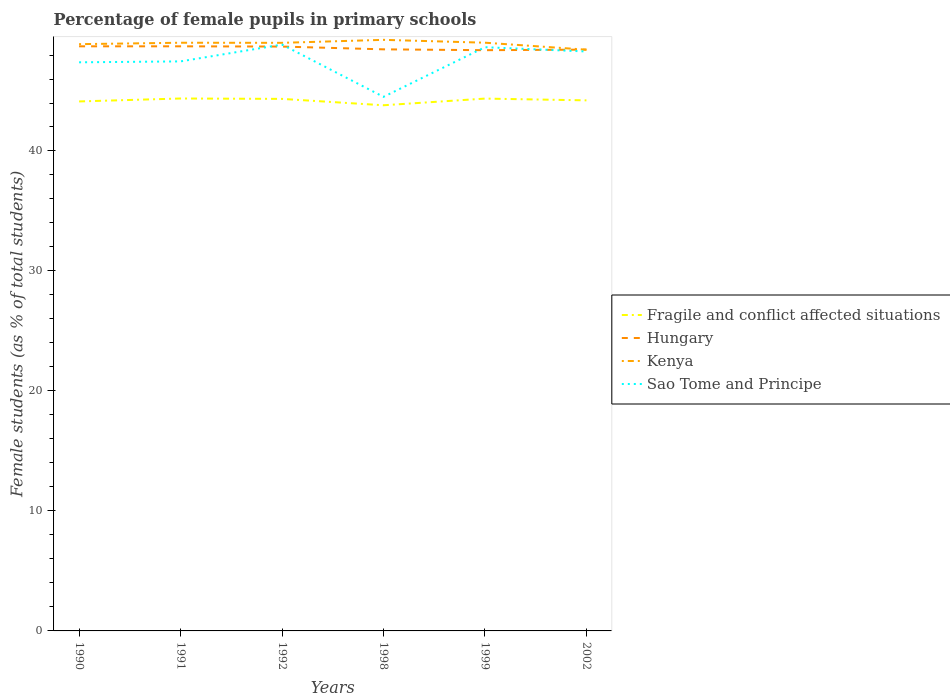Does the line corresponding to Kenya intersect with the line corresponding to Fragile and conflict affected situations?
Your response must be concise. No. Is the number of lines equal to the number of legend labels?
Your answer should be very brief. Yes. Across all years, what is the maximum percentage of female pupils in primary schools in Kenya?
Keep it short and to the point. 48.44. In which year was the percentage of female pupils in primary schools in Sao Tome and Principe maximum?
Provide a succinct answer. 1998. What is the total percentage of female pupils in primary schools in Hungary in the graph?
Your answer should be compact. 0.25. What is the difference between the highest and the second highest percentage of female pupils in primary schools in Fragile and conflict affected situations?
Ensure brevity in your answer.  0.56. Is the percentage of female pupils in primary schools in Hungary strictly greater than the percentage of female pupils in primary schools in Kenya over the years?
Offer a terse response. No. How many lines are there?
Offer a very short reply. 4. How many years are there in the graph?
Your answer should be compact. 6. What is the difference between two consecutive major ticks on the Y-axis?
Your response must be concise. 10. Does the graph contain any zero values?
Ensure brevity in your answer.  No. How many legend labels are there?
Your answer should be very brief. 4. How are the legend labels stacked?
Offer a very short reply. Vertical. What is the title of the graph?
Ensure brevity in your answer.  Percentage of female pupils in primary schools. Does "Kiribati" appear as one of the legend labels in the graph?
Make the answer very short. No. What is the label or title of the Y-axis?
Keep it short and to the point. Female students (as % of total students). What is the Female students (as % of total students) in Fragile and conflict affected situations in 1990?
Make the answer very short. 44.13. What is the Female students (as % of total students) of Hungary in 1990?
Offer a terse response. 48.72. What is the Female students (as % of total students) in Kenya in 1990?
Make the answer very short. 48.9. What is the Female students (as % of total students) in Sao Tome and Principe in 1990?
Your answer should be compact. 47.39. What is the Female students (as % of total students) in Fragile and conflict affected situations in 1991?
Your answer should be compact. 44.38. What is the Female students (as % of total students) of Hungary in 1991?
Keep it short and to the point. 48.72. What is the Female students (as % of total students) in Kenya in 1991?
Your answer should be very brief. 49.02. What is the Female students (as % of total students) in Sao Tome and Principe in 1991?
Offer a very short reply. 47.47. What is the Female students (as % of total students) of Fragile and conflict affected situations in 1992?
Your answer should be compact. 44.34. What is the Female students (as % of total students) of Hungary in 1992?
Offer a terse response. 48.7. What is the Female students (as % of total students) in Kenya in 1992?
Provide a short and direct response. 49.02. What is the Female students (as % of total students) of Sao Tome and Principe in 1992?
Your answer should be very brief. 48.87. What is the Female students (as % of total students) of Fragile and conflict affected situations in 1998?
Offer a very short reply. 43.81. What is the Female students (as % of total students) of Hungary in 1998?
Ensure brevity in your answer.  48.47. What is the Female students (as % of total students) in Kenya in 1998?
Offer a terse response. 49.26. What is the Female students (as % of total students) of Sao Tome and Principe in 1998?
Give a very brief answer. 44.51. What is the Female students (as % of total students) of Fragile and conflict affected situations in 1999?
Ensure brevity in your answer.  44.37. What is the Female students (as % of total students) of Hungary in 1999?
Make the answer very short. 48.4. What is the Female students (as % of total students) of Kenya in 1999?
Make the answer very short. 49.03. What is the Female students (as % of total students) in Sao Tome and Principe in 1999?
Offer a very short reply. 48.65. What is the Female students (as % of total students) of Fragile and conflict affected situations in 2002?
Make the answer very short. 44.22. What is the Female students (as % of total students) in Hungary in 2002?
Keep it short and to the point. 48.45. What is the Female students (as % of total students) of Kenya in 2002?
Offer a terse response. 48.44. What is the Female students (as % of total students) in Sao Tome and Principe in 2002?
Provide a succinct answer. 48.29. Across all years, what is the maximum Female students (as % of total students) in Fragile and conflict affected situations?
Your answer should be compact. 44.38. Across all years, what is the maximum Female students (as % of total students) of Hungary?
Keep it short and to the point. 48.72. Across all years, what is the maximum Female students (as % of total students) in Kenya?
Offer a terse response. 49.26. Across all years, what is the maximum Female students (as % of total students) of Sao Tome and Principe?
Make the answer very short. 48.87. Across all years, what is the minimum Female students (as % of total students) of Fragile and conflict affected situations?
Offer a terse response. 43.81. Across all years, what is the minimum Female students (as % of total students) in Hungary?
Provide a short and direct response. 48.4. Across all years, what is the minimum Female students (as % of total students) of Kenya?
Your answer should be compact. 48.44. Across all years, what is the minimum Female students (as % of total students) of Sao Tome and Principe?
Your response must be concise. 44.51. What is the total Female students (as % of total students) in Fragile and conflict affected situations in the graph?
Your response must be concise. 265.25. What is the total Female students (as % of total students) in Hungary in the graph?
Keep it short and to the point. 291.48. What is the total Female students (as % of total students) of Kenya in the graph?
Offer a terse response. 293.68. What is the total Female students (as % of total students) of Sao Tome and Principe in the graph?
Provide a short and direct response. 285.19. What is the difference between the Female students (as % of total students) in Fragile and conflict affected situations in 1990 and that in 1991?
Your answer should be very brief. -0.25. What is the difference between the Female students (as % of total students) in Hungary in 1990 and that in 1991?
Offer a very short reply. -0. What is the difference between the Female students (as % of total students) in Kenya in 1990 and that in 1991?
Provide a short and direct response. -0.12. What is the difference between the Female students (as % of total students) in Sao Tome and Principe in 1990 and that in 1991?
Ensure brevity in your answer.  -0.08. What is the difference between the Female students (as % of total students) of Fragile and conflict affected situations in 1990 and that in 1992?
Offer a very short reply. -0.21. What is the difference between the Female students (as % of total students) in Hungary in 1990 and that in 1992?
Your response must be concise. 0.02. What is the difference between the Female students (as % of total students) in Kenya in 1990 and that in 1992?
Provide a short and direct response. -0.11. What is the difference between the Female students (as % of total students) of Sao Tome and Principe in 1990 and that in 1992?
Provide a short and direct response. -1.48. What is the difference between the Female students (as % of total students) in Fragile and conflict affected situations in 1990 and that in 1998?
Provide a succinct answer. 0.32. What is the difference between the Female students (as % of total students) in Hungary in 1990 and that in 1998?
Provide a short and direct response. 0.25. What is the difference between the Female students (as % of total students) of Kenya in 1990 and that in 1998?
Provide a short and direct response. -0.36. What is the difference between the Female students (as % of total students) in Sao Tome and Principe in 1990 and that in 1998?
Offer a very short reply. 2.88. What is the difference between the Female students (as % of total students) in Fragile and conflict affected situations in 1990 and that in 1999?
Provide a succinct answer. -0.24. What is the difference between the Female students (as % of total students) of Hungary in 1990 and that in 1999?
Ensure brevity in your answer.  0.32. What is the difference between the Female students (as % of total students) in Kenya in 1990 and that in 1999?
Give a very brief answer. -0.12. What is the difference between the Female students (as % of total students) in Sao Tome and Principe in 1990 and that in 1999?
Offer a very short reply. -1.26. What is the difference between the Female students (as % of total students) of Fragile and conflict affected situations in 1990 and that in 2002?
Keep it short and to the point. -0.09. What is the difference between the Female students (as % of total students) of Hungary in 1990 and that in 2002?
Give a very brief answer. 0.28. What is the difference between the Female students (as % of total students) of Kenya in 1990 and that in 2002?
Make the answer very short. 0.46. What is the difference between the Female students (as % of total students) in Sao Tome and Principe in 1990 and that in 2002?
Keep it short and to the point. -0.9. What is the difference between the Female students (as % of total students) of Fragile and conflict affected situations in 1991 and that in 1992?
Give a very brief answer. 0.03. What is the difference between the Female students (as % of total students) in Hungary in 1991 and that in 1992?
Your answer should be compact. 0.02. What is the difference between the Female students (as % of total students) of Kenya in 1991 and that in 1992?
Provide a short and direct response. 0.01. What is the difference between the Female students (as % of total students) of Sao Tome and Principe in 1991 and that in 1992?
Your response must be concise. -1.4. What is the difference between the Female students (as % of total students) in Fragile and conflict affected situations in 1991 and that in 1998?
Offer a very short reply. 0.56. What is the difference between the Female students (as % of total students) of Hungary in 1991 and that in 1998?
Give a very brief answer. 0.25. What is the difference between the Female students (as % of total students) in Kenya in 1991 and that in 1998?
Provide a succinct answer. -0.24. What is the difference between the Female students (as % of total students) in Sao Tome and Principe in 1991 and that in 1998?
Make the answer very short. 2.95. What is the difference between the Female students (as % of total students) in Fragile and conflict affected situations in 1991 and that in 1999?
Your answer should be very brief. 0.01. What is the difference between the Female students (as % of total students) in Hungary in 1991 and that in 1999?
Provide a short and direct response. 0.32. What is the difference between the Female students (as % of total students) in Kenya in 1991 and that in 1999?
Offer a very short reply. -0. What is the difference between the Female students (as % of total students) in Sao Tome and Principe in 1991 and that in 1999?
Give a very brief answer. -1.18. What is the difference between the Female students (as % of total students) of Fragile and conflict affected situations in 1991 and that in 2002?
Give a very brief answer. 0.16. What is the difference between the Female students (as % of total students) of Hungary in 1991 and that in 2002?
Your response must be concise. 0.28. What is the difference between the Female students (as % of total students) of Kenya in 1991 and that in 2002?
Give a very brief answer. 0.58. What is the difference between the Female students (as % of total students) in Sao Tome and Principe in 1991 and that in 2002?
Give a very brief answer. -0.83. What is the difference between the Female students (as % of total students) in Fragile and conflict affected situations in 1992 and that in 1998?
Provide a short and direct response. 0.53. What is the difference between the Female students (as % of total students) of Hungary in 1992 and that in 1998?
Ensure brevity in your answer.  0.23. What is the difference between the Female students (as % of total students) of Kenya in 1992 and that in 1998?
Provide a succinct answer. -0.25. What is the difference between the Female students (as % of total students) of Sao Tome and Principe in 1992 and that in 1998?
Ensure brevity in your answer.  4.36. What is the difference between the Female students (as % of total students) in Fragile and conflict affected situations in 1992 and that in 1999?
Keep it short and to the point. -0.03. What is the difference between the Female students (as % of total students) of Hungary in 1992 and that in 1999?
Ensure brevity in your answer.  0.3. What is the difference between the Female students (as % of total students) in Kenya in 1992 and that in 1999?
Provide a short and direct response. -0.01. What is the difference between the Female students (as % of total students) in Sao Tome and Principe in 1992 and that in 1999?
Offer a very short reply. 0.22. What is the difference between the Female students (as % of total students) in Fragile and conflict affected situations in 1992 and that in 2002?
Make the answer very short. 0.12. What is the difference between the Female students (as % of total students) of Hungary in 1992 and that in 2002?
Provide a short and direct response. 0.25. What is the difference between the Female students (as % of total students) of Kenya in 1992 and that in 2002?
Ensure brevity in your answer.  0.57. What is the difference between the Female students (as % of total students) in Sao Tome and Principe in 1992 and that in 2002?
Keep it short and to the point. 0.57. What is the difference between the Female students (as % of total students) of Fragile and conflict affected situations in 1998 and that in 1999?
Your answer should be compact. -0.56. What is the difference between the Female students (as % of total students) in Hungary in 1998 and that in 1999?
Your answer should be very brief. 0.07. What is the difference between the Female students (as % of total students) in Kenya in 1998 and that in 1999?
Provide a succinct answer. 0.24. What is the difference between the Female students (as % of total students) of Sao Tome and Principe in 1998 and that in 1999?
Your answer should be very brief. -4.14. What is the difference between the Female students (as % of total students) in Fragile and conflict affected situations in 1998 and that in 2002?
Provide a short and direct response. -0.41. What is the difference between the Female students (as % of total students) in Hungary in 1998 and that in 2002?
Offer a terse response. 0.02. What is the difference between the Female students (as % of total students) in Kenya in 1998 and that in 2002?
Offer a terse response. 0.82. What is the difference between the Female students (as % of total students) of Sao Tome and Principe in 1998 and that in 2002?
Your answer should be compact. -3.78. What is the difference between the Female students (as % of total students) of Fragile and conflict affected situations in 1999 and that in 2002?
Provide a succinct answer. 0.15. What is the difference between the Female students (as % of total students) of Hungary in 1999 and that in 2002?
Your answer should be compact. -0.05. What is the difference between the Female students (as % of total students) in Kenya in 1999 and that in 2002?
Your answer should be very brief. 0.58. What is the difference between the Female students (as % of total students) in Sao Tome and Principe in 1999 and that in 2002?
Your answer should be very brief. 0.36. What is the difference between the Female students (as % of total students) of Fragile and conflict affected situations in 1990 and the Female students (as % of total students) of Hungary in 1991?
Offer a terse response. -4.59. What is the difference between the Female students (as % of total students) of Fragile and conflict affected situations in 1990 and the Female students (as % of total students) of Kenya in 1991?
Offer a terse response. -4.89. What is the difference between the Female students (as % of total students) of Fragile and conflict affected situations in 1990 and the Female students (as % of total students) of Sao Tome and Principe in 1991?
Keep it short and to the point. -3.34. What is the difference between the Female students (as % of total students) in Hungary in 1990 and the Female students (as % of total students) in Kenya in 1991?
Provide a succinct answer. -0.3. What is the difference between the Female students (as % of total students) in Hungary in 1990 and the Female students (as % of total students) in Sao Tome and Principe in 1991?
Provide a short and direct response. 1.26. What is the difference between the Female students (as % of total students) of Kenya in 1990 and the Female students (as % of total students) of Sao Tome and Principe in 1991?
Your response must be concise. 1.44. What is the difference between the Female students (as % of total students) in Fragile and conflict affected situations in 1990 and the Female students (as % of total students) in Hungary in 1992?
Offer a terse response. -4.57. What is the difference between the Female students (as % of total students) of Fragile and conflict affected situations in 1990 and the Female students (as % of total students) of Kenya in 1992?
Ensure brevity in your answer.  -4.89. What is the difference between the Female students (as % of total students) in Fragile and conflict affected situations in 1990 and the Female students (as % of total students) in Sao Tome and Principe in 1992?
Provide a succinct answer. -4.74. What is the difference between the Female students (as % of total students) in Hungary in 1990 and the Female students (as % of total students) in Kenya in 1992?
Ensure brevity in your answer.  -0.29. What is the difference between the Female students (as % of total students) of Hungary in 1990 and the Female students (as % of total students) of Sao Tome and Principe in 1992?
Your response must be concise. -0.14. What is the difference between the Female students (as % of total students) in Kenya in 1990 and the Female students (as % of total students) in Sao Tome and Principe in 1992?
Give a very brief answer. 0.04. What is the difference between the Female students (as % of total students) in Fragile and conflict affected situations in 1990 and the Female students (as % of total students) in Hungary in 1998?
Offer a very short reply. -4.34. What is the difference between the Female students (as % of total students) of Fragile and conflict affected situations in 1990 and the Female students (as % of total students) of Kenya in 1998?
Provide a succinct answer. -5.13. What is the difference between the Female students (as % of total students) in Fragile and conflict affected situations in 1990 and the Female students (as % of total students) in Sao Tome and Principe in 1998?
Your answer should be very brief. -0.38. What is the difference between the Female students (as % of total students) in Hungary in 1990 and the Female students (as % of total students) in Kenya in 1998?
Ensure brevity in your answer.  -0.54. What is the difference between the Female students (as % of total students) in Hungary in 1990 and the Female students (as % of total students) in Sao Tome and Principe in 1998?
Your response must be concise. 4.21. What is the difference between the Female students (as % of total students) in Kenya in 1990 and the Female students (as % of total students) in Sao Tome and Principe in 1998?
Make the answer very short. 4.39. What is the difference between the Female students (as % of total students) of Fragile and conflict affected situations in 1990 and the Female students (as % of total students) of Hungary in 1999?
Make the answer very short. -4.27. What is the difference between the Female students (as % of total students) of Fragile and conflict affected situations in 1990 and the Female students (as % of total students) of Kenya in 1999?
Offer a very short reply. -4.9. What is the difference between the Female students (as % of total students) of Fragile and conflict affected situations in 1990 and the Female students (as % of total students) of Sao Tome and Principe in 1999?
Offer a very short reply. -4.52. What is the difference between the Female students (as % of total students) of Hungary in 1990 and the Female students (as % of total students) of Kenya in 1999?
Provide a short and direct response. -0.3. What is the difference between the Female students (as % of total students) of Hungary in 1990 and the Female students (as % of total students) of Sao Tome and Principe in 1999?
Your answer should be compact. 0.07. What is the difference between the Female students (as % of total students) of Kenya in 1990 and the Female students (as % of total students) of Sao Tome and Principe in 1999?
Provide a succinct answer. 0.25. What is the difference between the Female students (as % of total students) in Fragile and conflict affected situations in 1990 and the Female students (as % of total students) in Hungary in 2002?
Offer a very short reply. -4.32. What is the difference between the Female students (as % of total students) of Fragile and conflict affected situations in 1990 and the Female students (as % of total students) of Kenya in 2002?
Offer a very short reply. -4.31. What is the difference between the Female students (as % of total students) of Fragile and conflict affected situations in 1990 and the Female students (as % of total students) of Sao Tome and Principe in 2002?
Ensure brevity in your answer.  -4.16. What is the difference between the Female students (as % of total students) of Hungary in 1990 and the Female students (as % of total students) of Kenya in 2002?
Your answer should be compact. 0.28. What is the difference between the Female students (as % of total students) in Hungary in 1990 and the Female students (as % of total students) in Sao Tome and Principe in 2002?
Your answer should be compact. 0.43. What is the difference between the Female students (as % of total students) in Kenya in 1990 and the Female students (as % of total students) in Sao Tome and Principe in 2002?
Provide a succinct answer. 0.61. What is the difference between the Female students (as % of total students) in Fragile and conflict affected situations in 1991 and the Female students (as % of total students) in Hungary in 1992?
Make the answer very short. -4.33. What is the difference between the Female students (as % of total students) in Fragile and conflict affected situations in 1991 and the Female students (as % of total students) in Kenya in 1992?
Your answer should be compact. -4.64. What is the difference between the Female students (as % of total students) of Fragile and conflict affected situations in 1991 and the Female students (as % of total students) of Sao Tome and Principe in 1992?
Your answer should be compact. -4.49. What is the difference between the Female students (as % of total students) of Hungary in 1991 and the Female students (as % of total students) of Kenya in 1992?
Make the answer very short. -0.29. What is the difference between the Female students (as % of total students) of Hungary in 1991 and the Female students (as % of total students) of Sao Tome and Principe in 1992?
Provide a succinct answer. -0.14. What is the difference between the Female students (as % of total students) of Kenya in 1991 and the Female students (as % of total students) of Sao Tome and Principe in 1992?
Your response must be concise. 0.15. What is the difference between the Female students (as % of total students) of Fragile and conflict affected situations in 1991 and the Female students (as % of total students) of Hungary in 1998?
Give a very brief answer. -4.1. What is the difference between the Female students (as % of total students) in Fragile and conflict affected situations in 1991 and the Female students (as % of total students) in Kenya in 1998?
Your answer should be very brief. -4.89. What is the difference between the Female students (as % of total students) in Fragile and conflict affected situations in 1991 and the Female students (as % of total students) in Sao Tome and Principe in 1998?
Offer a terse response. -0.14. What is the difference between the Female students (as % of total students) of Hungary in 1991 and the Female students (as % of total students) of Kenya in 1998?
Your response must be concise. -0.54. What is the difference between the Female students (as % of total students) in Hungary in 1991 and the Female students (as % of total students) in Sao Tome and Principe in 1998?
Your answer should be very brief. 4.21. What is the difference between the Female students (as % of total students) in Kenya in 1991 and the Female students (as % of total students) in Sao Tome and Principe in 1998?
Ensure brevity in your answer.  4.51. What is the difference between the Female students (as % of total students) in Fragile and conflict affected situations in 1991 and the Female students (as % of total students) in Hungary in 1999?
Provide a succinct answer. -4.03. What is the difference between the Female students (as % of total students) in Fragile and conflict affected situations in 1991 and the Female students (as % of total students) in Kenya in 1999?
Provide a succinct answer. -4.65. What is the difference between the Female students (as % of total students) of Fragile and conflict affected situations in 1991 and the Female students (as % of total students) of Sao Tome and Principe in 1999?
Give a very brief answer. -4.28. What is the difference between the Female students (as % of total students) of Hungary in 1991 and the Female students (as % of total students) of Kenya in 1999?
Keep it short and to the point. -0.3. What is the difference between the Female students (as % of total students) of Hungary in 1991 and the Female students (as % of total students) of Sao Tome and Principe in 1999?
Ensure brevity in your answer.  0.07. What is the difference between the Female students (as % of total students) in Kenya in 1991 and the Female students (as % of total students) in Sao Tome and Principe in 1999?
Give a very brief answer. 0.37. What is the difference between the Female students (as % of total students) in Fragile and conflict affected situations in 1991 and the Female students (as % of total students) in Hungary in 2002?
Offer a very short reply. -4.07. What is the difference between the Female students (as % of total students) of Fragile and conflict affected situations in 1991 and the Female students (as % of total students) of Kenya in 2002?
Your answer should be very brief. -4.07. What is the difference between the Female students (as % of total students) of Fragile and conflict affected situations in 1991 and the Female students (as % of total students) of Sao Tome and Principe in 2002?
Offer a very short reply. -3.92. What is the difference between the Female students (as % of total students) of Hungary in 1991 and the Female students (as % of total students) of Kenya in 2002?
Give a very brief answer. 0.28. What is the difference between the Female students (as % of total students) of Hungary in 1991 and the Female students (as % of total students) of Sao Tome and Principe in 2002?
Provide a short and direct response. 0.43. What is the difference between the Female students (as % of total students) in Kenya in 1991 and the Female students (as % of total students) in Sao Tome and Principe in 2002?
Your answer should be very brief. 0.73. What is the difference between the Female students (as % of total students) in Fragile and conflict affected situations in 1992 and the Female students (as % of total students) in Hungary in 1998?
Your answer should be compact. -4.13. What is the difference between the Female students (as % of total students) of Fragile and conflict affected situations in 1992 and the Female students (as % of total students) of Kenya in 1998?
Provide a succinct answer. -4.92. What is the difference between the Female students (as % of total students) of Fragile and conflict affected situations in 1992 and the Female students (as % of total students) of Sao Tome and Principe in 1998?
Offer a very short reply. -0.17. What is the difference between the Female students (as % of total students) of Hungary in 1992 and the Female students (as % of total students) of Kenya in 1998?
Your answer should be very brief. -0.56. What is the difference between the Female students (as % of total students) of Hungary in 1992 and the Female students (as % of total students) of Sao Tome and Principe in 1998?
Your answer should be very brief. 4.19. What is the difference between the Female students (as % of total students) of Kenya in 1992 and the Female students (as % of total students) of Sao Tome and Principe in 1998?
Make the answer very short. 4.5. What is the difference between the Female students (as % of total students) of Fragile and conflict affected situations in 1992 and the Female students (as % of total students) of Hungary in 1999?
Offer a very short reply. -4.06. What is the difference between the Female students (as % of total students) in Fragile and conflict affected situations in 1992 and the Female students (as % of total students) in Kenya in 1999?
Ensure brevity in your answer.  -4.68. What is the difference between the Female students (as % of total students) in Fragile and conflict affected situations in 1992 and the Female students (as % of total students) in Sao Tome and Principe in 1999?
Provide a succinct answer. -4.31. What is the difference between the Female students (as % of total students) of Hungary in 1992 and the Female students (as % of total students) of Kenya in 1999?
Ensure brevity in your answer.  -0.32. What is the difference between the Female students (as % of total students) of Hungary in 1992 and the Female students (as % of total students) of Sao Tome and Principe in 1999?
Offer a terse response. 0.05. What is the difference between the Female students (as % of total students) of Kenya in 1992 and the Female students (as % of total students) of Sao Tome and Principe in 1999?
Offer a terse response. 0.36. What is the difference between the Female students (as % of total students) in Fragile and conflict affected situations in 1992 and the Female students (as % of total students) in Hungary in 2002?
Keep it short and to the point. -4.11. What is the difference between the Female students (as % of total students) of Fragile and conflict affected situations in 1992 and the Female students (as % of total students) of Kenya in 2002?
Provide a succinct answer. -4.1. What is the difference between the Female students (as % of total students) of Fragile and conflict affected situations in 1992 and the Female students (as % of total students) of Sao Tome and Principe in 2002?
Offer a very short reply. -3.95. What is the difference between the Female students (as % of total students) in Hungary in 1992 and the Female students (as % of total students) in Kenya in 2002?
Provide a short and direct response. 0.26. What is the difference between the Female students (as % of total students) of Hungary in 1992 and the Female students (as % of total students) of Sao Tome and Principe in 2002?
Your response must be concise. 0.41. What is the difference between the Female students (as % of total students) in Kenya in 1992 and the Female students (as % of total students) in Sao Tome and Principe in 2002?
Your answer should be very brief. 0.72. What is the difference between the Female students (as % of total students) of Fragile and conflict affected situations in 1998 and the Female students (as % of total students) of Hungary in 1999?
Your response must be concise. -4.59. What is the difference between the Female students (as % of total students) in Fragile and conflict affected situations in 1998 and the Female students (as % of total students) in Kenya in 1999?
Offer a very short reply. -5.21. What is the difference between the Female students (as % of total students) in Fragile and conflict affected situations in 1998 and the Female students (as % of total students) in Sao Tome and Principe in 1999?
Offer a terse response. -4.84. What is the difference between the Female students (as % of total students) in Hungary in 1998 and the Female students (as % of total students) in Kenya in 1999?
Offer a terse response. -0.55. What is the difference between the Female students (as % of total students) of Hungary in 1998 and the Female students (as % of total students) of Sao Tome and Principe in 1999?
Offer a terse response. -0.18. What is the difference between the Female students (as % of total students) of Kenya in 1998 and the Female students (as % of total students) of Sao Tome and Principe in 1999?
Make the answer very short. 0.61. What is the difference between the Female students (as % of total students) of Fragile and conflict affected situations in 1998 and the Female students (as % of total students) of Hungary in 2002?
Your answer should be very brief. -4.64. What is the difference between the Female students (as % of total students) in Fragile and conflict affected situations in 1998 and the Female students (as % of total students) in Kenya in 2002?
Give a very brief answer. -4.63. What is the difference between the Female students (as % of total students) of Fragile and conflict affected situations in 1998 and the Female students (as % of total students) of Sao Tome and Principe in 2002?
Offer a very short reply. -4.48. What is the difference between the Female students (as % of total students) in Hungary in 1998 and the Female students (as % of total students) in Kenya in 2002?
Provide a short and direct response. 0.03. What is the difference between the Female students (as % of total students) in Hungary in 1998 and the Female students (as % of total students) in Sao Tome and Principe in 2002?
Your answer should be very brief. 0.18. What is the difference between the Female students (as % of total students) of Kenya in 1998 and the Female students (as % of total students) of Sao Tome and Principe in 2002?
Provide a short and direct response. 0.97. What is the difference between the Female students (as % of total students) in Fragile and conflict affected situations in 1999 and the Female students (as % of total students) in Hungary in 2002?
Provide a succinct answer. -4.08. What is the difference between the Female students (as % of total students) of Fragile and conflict affected situations in 1999 and the Female students (as % of total students) of Kenya in 2002?
Offer a terse response. -4.08. What is the difference between the Female students (as % of total students) in Fragile and conflict affected situations in 1999 and the Female students (as % of total students) in Sao Tome and Principe in 2002?
Ensure brevity in your answer.  -3.93. What is the difference between the Female students (as % of total students) in Hungary in 1999 and the Female students (as % of total students) in Kenya in 2002?
Your response must be concise. -0.04. What is the difference between the Female students (as % of total students) in Hungary in 1999 and the Female students (as % of total students) in Sao Tome and Principe in 2002?
Your response must be concise. 0.11. What is the difference between the Female students (as % of total students) in Kenya in 1999 and the Female students (as % of total students) in Sao Tome and Principe in 2002?
Make the answer very short. 0.73. What is the average Female students (as % of total students) of Fragile and conflict affected situations per year?
Make the answer very short. 44.21. What is the average Female students (as % of total students) of Hungary per year?
Your answer should be very brief. 48.58. What is the average Female students (as % of total students) of Kenya per year?
Your answer should be compact. 48.95. What is the average Female students (as % of total students) in Sao Tome and Principe per year?
Ensure brevity in your answer.  47.53. In the year 1990, what is the difference between the Female students (as % of total students) of Fragile and conflict affected situations and Female students (as % of total students) of Hungary?
Keep it short and to the point. -4.59. In the year 1990, what is the difference between the Female students (as % of total students) of Fragile and conflict affected situations and Female students (as % of total students) of Kenya?
Make the answer very short. -4.77. In the year 1990, what is the difference between the Female students (as % of total students) of Fragile and conflict affected situations and Female students (as % of total students) of Sao Tome and Principe?
Offer a terse response. -3.26. In the year 1990, what is the difference between the Female students (as % of total students) in Hungary and Female students (as % of total students) in Kenya?
Give a very brief answer. -0.18. In the year 1990, what is the difference between the Female students (as % of total students) of Hungary and Female students (as % of total students) of Sao Tome and Principe?
Ensure brevity in your answer.  1.33. In the year 1990, what is the difference between the Female students (as % of total students) of Kenya and Female students (as % of total students) of Sao Tome and Principe?
Ensure brevity in your answer.  1.51. In the year 1991, what is the difference between the Female students (as % of total students) in Fragile and conflict affected situations and Female students (as % of total students) in Hungary?
Keep it short and to the point. -4.35. In the year 1991, what is the difference between the Female students (as % of total students) in Fragile and conflict affected situations and Female students (as % of total students) in Kenya?
Ensure brevity in your answer.  -4.65. In the year 1991, what is the difference between the Female students (as % of total students) in Fragile and conflict affected situations and Female students (as % of total students) in Sao Tome and Principe?
Offer a very short reply. -3.09. In the year 1991, what is the difference between the Female students (as % of total students) in Hungary and Female students (as % of total students) in Kenya?
Provide a succinct answer. -0.3. In the year 1991, what is the difference between the Female students (as % of total students) of Hungary and Female students (as % of total students) of Sao Tome and Principe?
Give a very brief answer. 1.26. In the year 1991, what is the difference between the Female students (as % of total students) in Kenya and Female students (as % of total students) in Sao Tome and Principe?
Your response must be concise. 1.56. In the year 1992, what is the difference between the Female students (as % of total students) in Fragile and conflict affected situations and Female students (as % of total students) in Hungary?
Your answer should be compact. -4.36. In the year 1992, what is the difference between the Female students (as % of total students) in Fragile and conflict affected situations and Female students (as % of total students) in Kenya?
Your response must be concise. -4.67. In the year 1992, what is the difference between the Female students (as % of total students) in Fragile and conflict affected situations and Female students (as % of total students) in Sao Tome and Principe?
Your response must be concise. -4.53. In the year 1992, what is the difference between the Female students (as % of total students) in Hungary and Female students (as % of total students) in Kenya?
Provide a succinct answer. -0.31. In the year 1992, what is the difference between the Female students (as % of total students) of Hungary and Female students (as % of total students) of Sao Tome and Principe?
Give a very brief answer. -0.16. In the year 1992, what is the difference between the Female students (as % of total students) of Kenya and Female students (as % of total students) of Sao Tome and Principe?
Ensure brevity in your answer.  0.15. In the year 1998, what is the difference between the Female students (as % of total students) in Fragile and conflict affected situations and Female students (as % of total students) in Hungary?
Keep it short and to the point. -4.66. In the year 1998, what is the difference between the Female students (as % of total students) of Fragile and conflict affected situations and Female students (as % of total students) of Kenya?
Keep it short and to the point. -5.45. In the year 1998, what is the difference between the Female students (as % of total students) in Fragile and conflict affected situations and Female students (as % of total students) in Sao Tome and Principe?
Provide a short and direct response. -0.7. In the year 1998, what is the difference between the Female students (as % of total students) in Hungary and Female students (as % of total students) in Kenya?
Your answer should be compact. -0.79. In the year 1998, what is the difference between the Female students (as % of total students) in Hungary and Female students (as % of total students) in Sao Tome and Principe?
Make the answer very short. 3.96. In the year 1998, what is the difference between the Female students (as % of total students) of Kenya and Female students (as % of total students) of Sao Tome and Principe?
Provide a succinct answer. 4.75. In the year 1999, what is the difference between the Female students (as % of total students) in Fragile and conflict affected situations and Female students (as % of total students) in Hungary?
Keep it short and to the point. -4.03. In the year 1999, what is the difference between the Female students (as % of total students) of Fragile and conflict affected situations and Female students (as % of total students) of Kenya?
Offer a terse response. -4.66. In the year 1999, what is the difference between the Female students (as % of total students) of Fragile and conflict affected situations and Female students (as % of total students) of Sao Tome and Principe?
Give a very brief answer. -4.28. In the year 1999, what is the difference between the Female students (as % of total students) of Hungary and Female students (as % of total students) of Kenya?
Your response must be concise. -0.62. In the year 1999, what is the difference between the Female students (as % of total students) of Hungary and Female students (as % of total students) of Sao Tome and Principe?
Offer a terse response. -0.25. In the year 1999, what is the difference between the Female students (as % of total students) in Kenya and Female students (as % of total students) in Sao Tome and Principe?
Ensure brevity in your answer.  0.37. In the year 2002, what is the difference between the Female students (as % of total students) of Fragile and conflict affected situations and Female students (as % of total students) of Hungary?
Your response must be concise. -4.23. In the year 2002, what is the difference between the Female students (as % of total students) of Fragile and conflict affected situations and Female students (as % of total students) of Kenya?
Your answer should be very brief. -4.22. In the year 2002, what is the difference between the Female students (as % of total students) of Fragile and conflict affected situations and Female students (as % of total students) of Sao Tome and Principe?
Give a very brief answer. -4.07. In the year 2002, what is the difference between the Female students (as % of total students) in Hungary and Female students (as % of total students) in Kenya?
Make the answer very short. 0.01. In the year 2002, what is the difference between the Female students (as % of total students) in Hungary and Female students (as % of total students) in Sao Tome and Principe?
Make the answer very short. 0.16. In the year 2002, what is the difference between the Female students (as % of total students) of Kenya and Female students (as % of total students) of Sao Tome and Principe?
Offer a terse response. 0.15. What is the ratio of the Female students (as % of total students) in Hungary in 1990 to that in 1991?
Keep it short and to the point. 1. What is the ratio of the Female students (as % of total students) in Sao Tome and Principe in 1990 to that in 1991?
Your answer should be compact. 1. What is the ratio of the Female students (as % of total students) in Hungary in 1990 to that in 1992?
Ensure brevity in your answer.  1. What is the ratio of the Female students (as % of total students) of Sao Tome and Principe in 1990 to that in 1992?
Your answer should be very brief. 0.97. What is the ratio of the Female students (as % of total students) of Fragile and conflict affected situations in 1990 to that in 1998?
Ensure brevity in your answer.  1.01. What is the ratio of the Female students (as % of total students) in Hungary in 1990 to that in 1998?
Your answer should be very brief. 1.01. What is the ratio of the Female students (as % of total students) in Sao Tome and Principe in 1990 to that in 1998?
Offer a terse response. 1.06. What is the ratio of the Female students (as % of total students) in Fragile and conflict affected situations in 1990 to that in 1999?
Give a very brief answer. 0.99. What is the ratio of the Female students (as % of total students) in Kenya in 1990 to that in 1999?
Make the answer very short. 1. What is the ratio of the Female students (as % of total students) of Sao Tome and Principe in 1990 to that in 1999?
Give a very brief answer. 0.97. What is the ratio of the Female students (as % of total students) in Fragile and conflict affected situations in 1990 to that in 2002?
Offer a terse response. 1. What is the ratio of the Female students (as % of total students) in Hungary in 1990 to that in 2002?
Your response must be concise. 1.01. What is the ratio of the Female students (as % of total students) in Kenya in 1990 to that in 2002?
Your answer should be very brief. 1.01. What is the ratio of the Female students (as % of total students) in Sao Tome and Principe in 1990 to that in 2002?
Keep it short and to the point. 0.98. What is the ratio of the Female students (as % of total students) of Fragile and conflict affected situations in 1991 to that in 1992?
Make the answer very short. 1. What is the ratio of the Female students (as % of total students) in Kenya in 1991 to that in 1992?
Provide a short and direct response. 1. What is the ratio of the Female students (as % of total students) in Sao Tome and Principe in 1991 to that in 1992?
Your response must be concise. 0.97. What is the ratio of the Female students (as % of total students) of Fragile and conflict affected situations in 1991 to that in 1998?
Give a very brief answer. 1.01. What is the ratio of the Female students (as % of total students) of Hungary in 1991 to that in 1998?
Keep it short and to the point. 1.01. What is the ratio of the Female students (as % of total students) in Sao Tome and Principe in 1991 to that in 1998?
Ensure brevity in your answer.  1.07. What is the ratio of the Female students (as % of total students) of Kenya in 1991 to that in 1999?
Your answer should be very brief. 1. What is the ratio of the Female students (as % of total students) in Sao Tome and Principe in 1991 to that in 1999?
Ensure brevity in your answer.  0.98. What is the ratio of the Female students (as % of total students) of Kenya in 1991 to that in 2002?
Your answer should be compact. 1.01. What is the ratio of the Female students (as % of total students) of Sao Tome and Principe in 1991 to that in 2002?
Give a very brief answer. 0.98. What is the ratio of the Female students (as % of total students) of Fragile and conflict affected situations in 1992 to that in 1998?
Offer a terse response. 1.01. What is the ratio of the Female students (as % of total students) of Hungary in 1992 to that in 1998?
Provide a succinct answer. 1. What is the ratio of the Female students (as % of total students) in Kenya in 1992 to that in 1998?
Your answer should be very brief. 0.99. What is the ratio of the Female students (as % of total students) in Sao Tome and Principe in 1992 to that in 1998?
Give a very brief answer. 1.1. What is the ratio of the Female students (as % of total students) in Fragile and conflict affected situations in 1992 to that in 1999?
Provide a succinct answer. 1. What is the ratio of the Female students (as % of total students) in Kenya in 1992 to that in 1999?
Provide a short and direct response. 1. What is the ratio of the Female students (as % of total students) in Sao Tome and Principe in 1992 to that in 1999?
Offer a very short reply. 1. What is the ratio of the Female students (as % of total students) of Fragile and conflict affected situations in 1992 to that in 2002?
Offer a very short reply. 1. What is the ratio of the Female students (as % of total students) of Hungary in 1992 to that in 2002?
Your answer should be compact. 1.01. What is the ratio of the Female students (as % of total students) of Kenya in 1992 to that in 2002?
Provide a succinct answer. 1.01. What is the ratio of the Female students (as % of total students) of Sao Tome and Principe in 1992 to that in 2002?
Offer a terse response. 1.01. What is the ratio of the Female students (as % of total students) of Fragile and conflict affected situations in 1998 to that in 1999?
Offer a very short reply. 0.99. What is the ratio of the Female students (as % of total students) of Hungary in 1998 to that in 1999?
Your response must be concise. 1. What is the ratio of the Female students (as % of total students) of Kenya in 1998 to that in 1999?
Keep it short and to the point. 1. What is the ratio of the Female students (as % of total students) in Sao Tome and Principe in 1998 to that in 1999?
Offer a terse response. 0.91. What is the ratio of the Female students (as % of total students) in Kenya in 1998 to that in 2002?
Provide a succinct answer. 1.02. What is the ratio of the Female students (as % of total students) in Sao Tome and Principe in 1998 to that in 2002?
Ensure brevity in your answer.  0.92. What is the ratio of the Female students (as % of total students) of Hungary in 1999 to that in 2002?
Ensure brevity in your answer.  1. What is the ratio of the Female students (as % of total students) of Kenya in 1999 to that in 2002?
Provide a succinct answer. 1.01. What is the ratio of the Female students (as % of total students) in Sao Tome and Principe in 1999 to that in 2002?
Give a very brief answer. 1.01. What is the difference between the highest and the second highest Female students (as % of total students) of Fragile and conflict affected situations?
Provide a short and direct response. 0.01. What is the difference between the highest and the second highest Female students (as % of total students) of Kenya?
Your answer should be compact. 0.24. What is the difference between the highest and the second highest Female students (as % of total students) in Sao Tome and Principe?
Provide a succinct answer. 0.22. What is the difference between the highest and the lowest Female students (as % of total students) in Fragile and conflict affected situations?
Offer a terse response. 0.56. What is the difference between the highest and the lowest Female students (as % of total students) in Hungary?
Offer a very short reply. 0.32. What is the difference between the highest and the lowest Female students (as % of total students) in Kenya?
Offer a terse response. 0.82. What is the difference between the highest and the lowest Female students (as % of total students) of Sao Tome and Principe?
Provide a succinct answer. 4.36. 